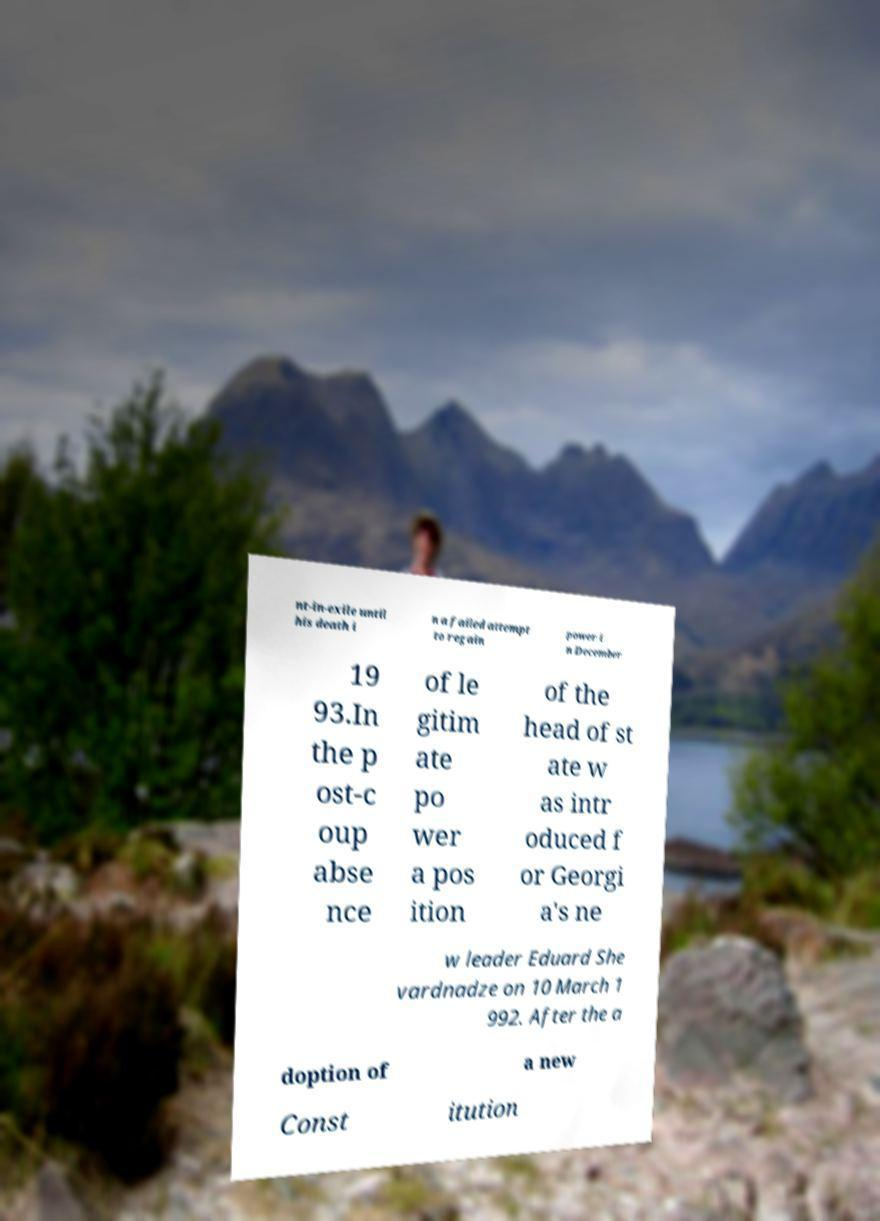There's text embedded in this image that I need extracted. Can you transcribe it verbatim? nt-in-exile until his death i n a failed attempt to regain power i n December 19 93.In the p ost-c oup abse nce of le gitim ate po wer a pos ition of the head of st ate w as intr oduced f or Georgi a's ne w leader Eduard She vardnadze on 10 March 1 992. After the a doption of a new Const itution 